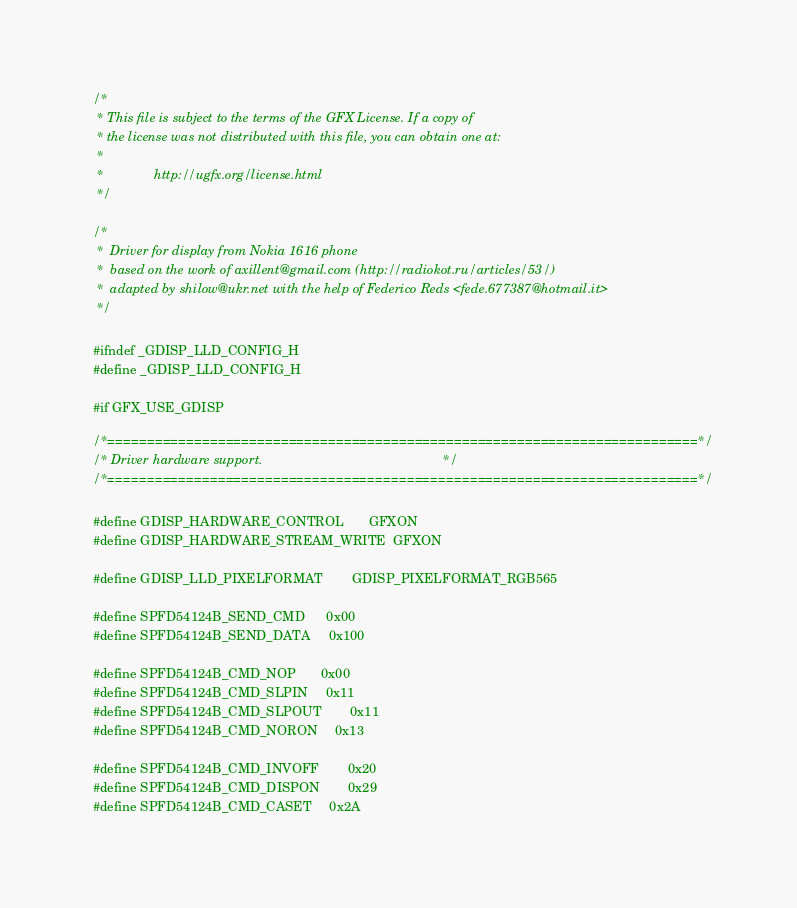<code> <loc_0><loc_0><loc_500><loc_500><_C_>/*
 * This file is subject to the terms of the GFX License. If a copy of
 * the license was not distributed with this file, you can obtain one at:
 *
 *              http://ugfx.org/license.html
 */

/* 
 *	Driver for display from Nokia 1616 phone
 *	based on the work of axillent@gmail.com (http://radiokot.ru/articles/53/)
 *	adapted by shilow@ukr.net with the help of Federico Reds <fede.677387@hotmail.it>
 */

#ifndef _GDISP_LLD_CONFIG_H
#define _GDISP_LLD_CONFIG_H

#if GFX_USE_GDISP 

/*===========================================================================*/
/* Driver hardware support.                                                  */
/*===========================================================================*/

#define GDISP_HARDWARE_CONTROL		GFXON
#define GDISP_HARDWARE_STREAM_WRITE	GFXON

#define GDISP_LLD_PIXELFORMAT		GDISP_PIXELFORMAT_RGB565

#define SPFD54124B_SEND_CMD		0x00
#define SPFD54124B_SEND_DATA		0x100

#define SPFD54124B_CMD_NOP		0x00
#define SPFD54124B_CMD_SLPIN		0x11
#define SPFD54124B_CMD_SLPOUT		0x11
#define SPFD54124B_CMD_NORON		0x13

#define SPFD54124B_CMD_INVOFF		0x20
#define SPFD54124B_CMD_DISPON		0x29
#define SPFD54124B_CMD_CASET		0x2A</code> 